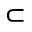<formula> <loc_0><loc_0><loc_500><loc_500>\subset</formula> 